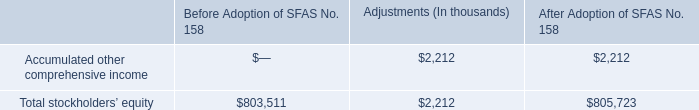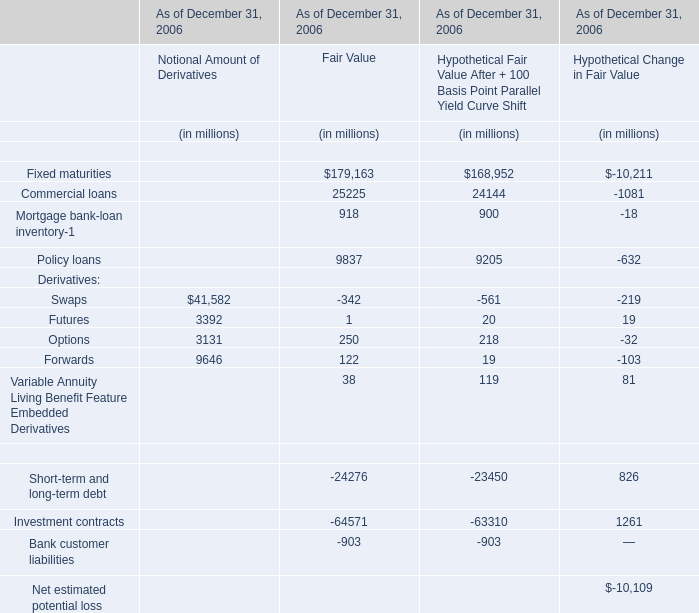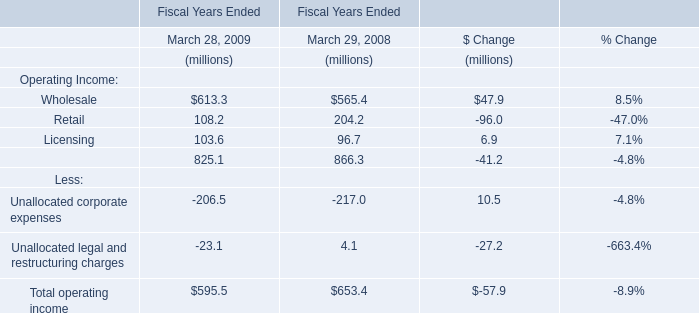What is the Notional Amount of Derivatives:Swaps As of December 31, 2006 as As the chart 1 shows? (in million) 
Answer: 41582. 